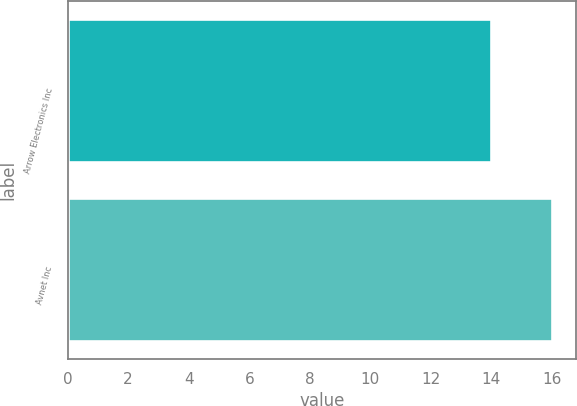<chart> <loc_0><loc_0><loc_500><loc_500><bar_chart><fcel>Arrow Electronics Inc<fcel>Avnet Inc<nl><fcel>14<fcel>16<nl></chart> 